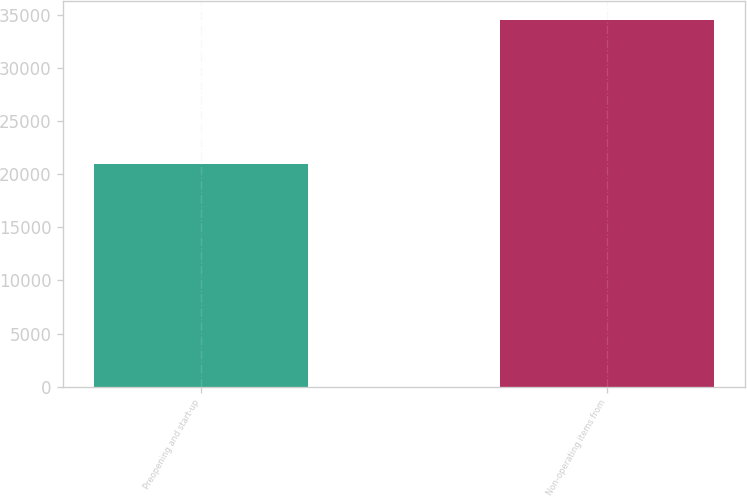Convert chart. <chart><loc_0><loc_0><loc_500><loc_500><bar_chart><fcel>Preopening and start-up<fcel>Non-operating items from<nl><fcel>20960<fcel>34559<nl></chart> 